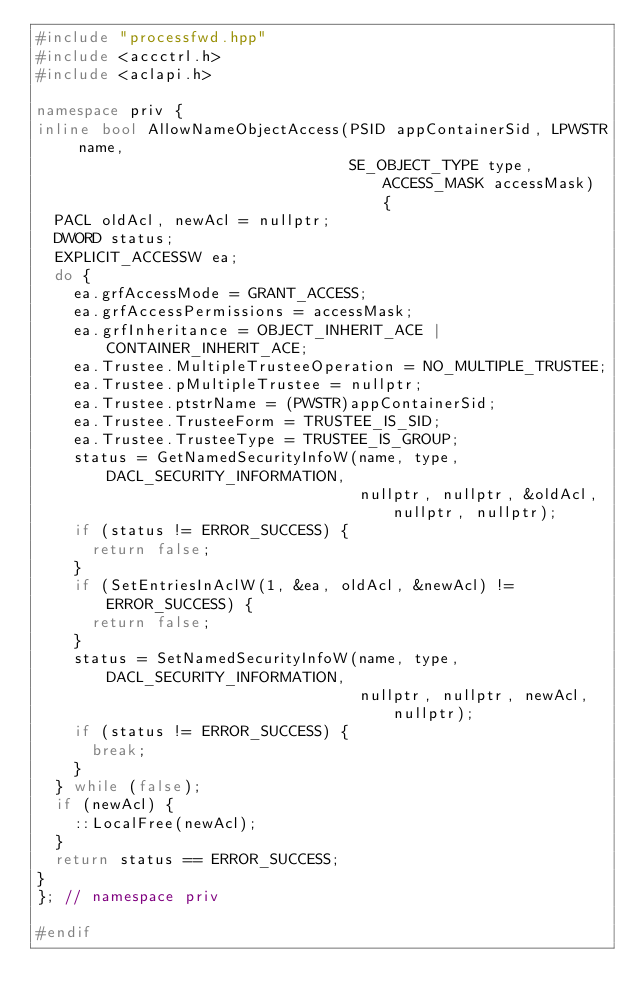<code> <loc_0><loc_0><loc_500><loc_500><_C++_>#include "processfwd.hpp"
#include <accctrl.h>
#include <aclapi.h>

namespace priv {
inline bool AllowNameObjectAccess(PSID appContainerSid, LPWSTR name,
                                  SE_OBJECT_TYPE type, ACCESS_MASK accessMask) {
  PACL oldAcl, newAcl = nullptr;
  DWORD status;
  EXPLICIT_ACCESSW ea;
  do {
    ea.grfAccessMode = GRANT_ACCESS;
    ea.grfAccessPermissions = accessMask;
    ea.grfInheritance = OBJECT_INHERIT_ACE | CONTAINER_INHERIT_ACE;
    ea.Trustee.MultipleTrusteeOperation = NO_MULTIPLE_TRUSTEE;
    ea.Trustee.pMultipleTrustee = nullptr;
    ea.Trustee.ptstrName = (PWSTR)appContainerSid;
    ea.Trustee.TrusteeForm = TRUSTEE_IS_SID;
    ea.Trustee.TrusteeType = TRUSTEE_IS_GROUP;
    status = GetNamedSecurityInfoW(name, type, DACL_SECURITY_INFORMATION,
                                   nullptr, nullptr, &oldAcl, nullptr, nullptr);
    if (status != ERROR_SUCCESS) {
      return false;
    }
    if (SetEntriesInAclW(1, &ea, oldAcl, &newAcl) != ERROR_SUCCESS) {
      return false;
    }
    status = SetNamedSecurityInfoW(name, type, DACL_SECURITY_INFORMATION,
                                   nullptr, nullptr, newAcl, nullptr);
    if (status != ERROR_SUCCESS) {
      break;
    }
  } while (false);
  if (newAcl) {
    ::LocalFree(newAcl);
  }
  return status == ERROR_SUCCESS;
}
}; // namespace priv

#endif</code> 